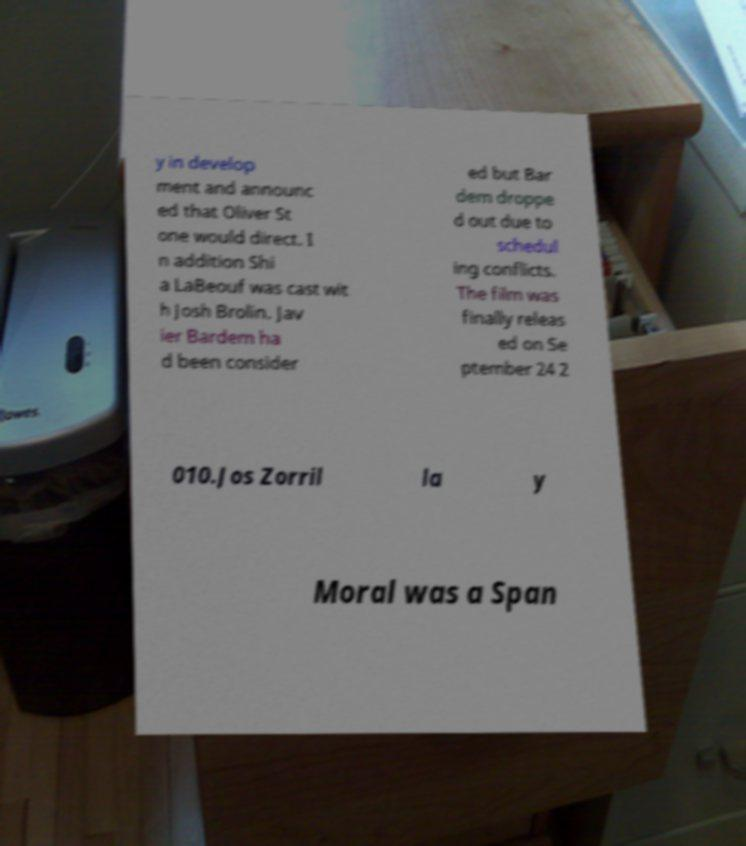Please identify and transcribe the text found in this image. y in develop ment and announc ed that Oliver St one would direct. I n addition Shi a LaBeouf was cast wit h Josh Brolin. Jav ier Bardem ha d been consider ed but Bar dem droppe d out due to schedul ing conflicts. The film was finally releas ed on Se ptember 24 2 010.Jos Zorril la y Moral was a Span 